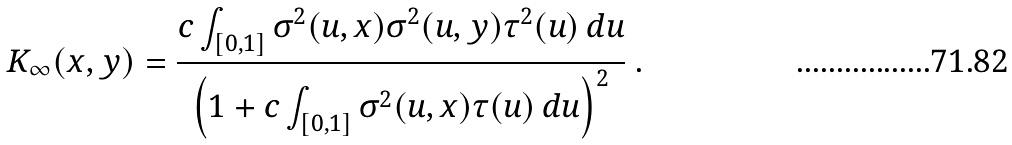Convert formula to latex. <formula><loc_0><loc_0><loc_500><loc_500>K _ { \infty } ( x , y ) = \frac { c \int _ { [ 0 , 1 ] } \sigma ^ { 2 } ( u , x ) \sigma ^ { 2 } ( u , y ) \tau ^ { 2 } ( u ) \, d u } { \left ( 1 + c \int _ { [ 0 , 1 ] } \sigma ^ { 2 } ( u , x ) \tau ( u ) \, d u \right ) ^ { 2 } } \ .</formula> 